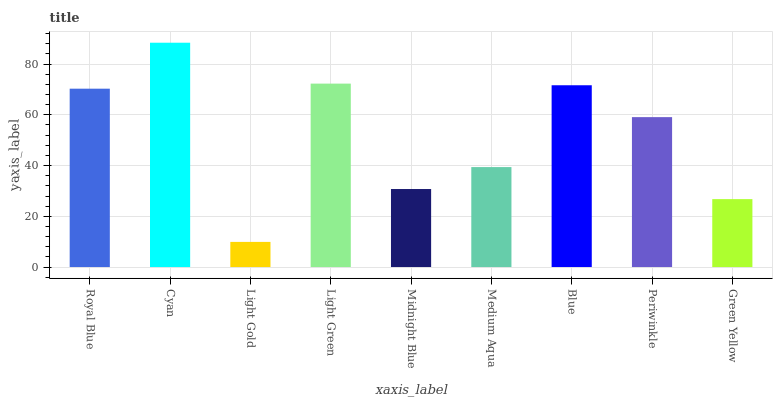Is Light Gold the minimum?
Answer yes or no. Yes. Is Cyan the maximum?
Answer yes or no. Yes. Is Cyan the minimum?
Answer yes or no. No. Is Light Gold the maximum?
Answer yes or no. No. Is Cyan greater than Light Gold?
Answer yes or no. Yes. Is Light Gold less than Cyan?
Answer yes or no. Yes. Is Light Gold greater than Cyan?
Answer yes or no. No. Is Cyan less than Light Gold?
Answer yes or no. No. Is Periwinkle the high median?
Answer yes or no. Yes. Is Periwinkle the low median?
Answer yes or no. Yes. Is Green Yellow the high median?
Answer yes or no. No. Is Cyan the low median?
Answer yes or no. No. 